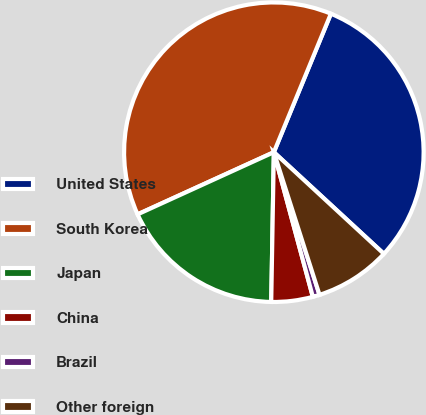<chart> <loc_0><loc_0><loc_500><loc_500><pie_chart><fcel>United States<fcel>South Korea<fcel>Japan<fcel>China<fcel>Brazil<fcel>Other foreign<nl><fcel>30.65%<fcel>38.03%<fcel>17.91%<fcel>4.47%<fcel>0.74%<fcel>8.2%<nl></chart> 